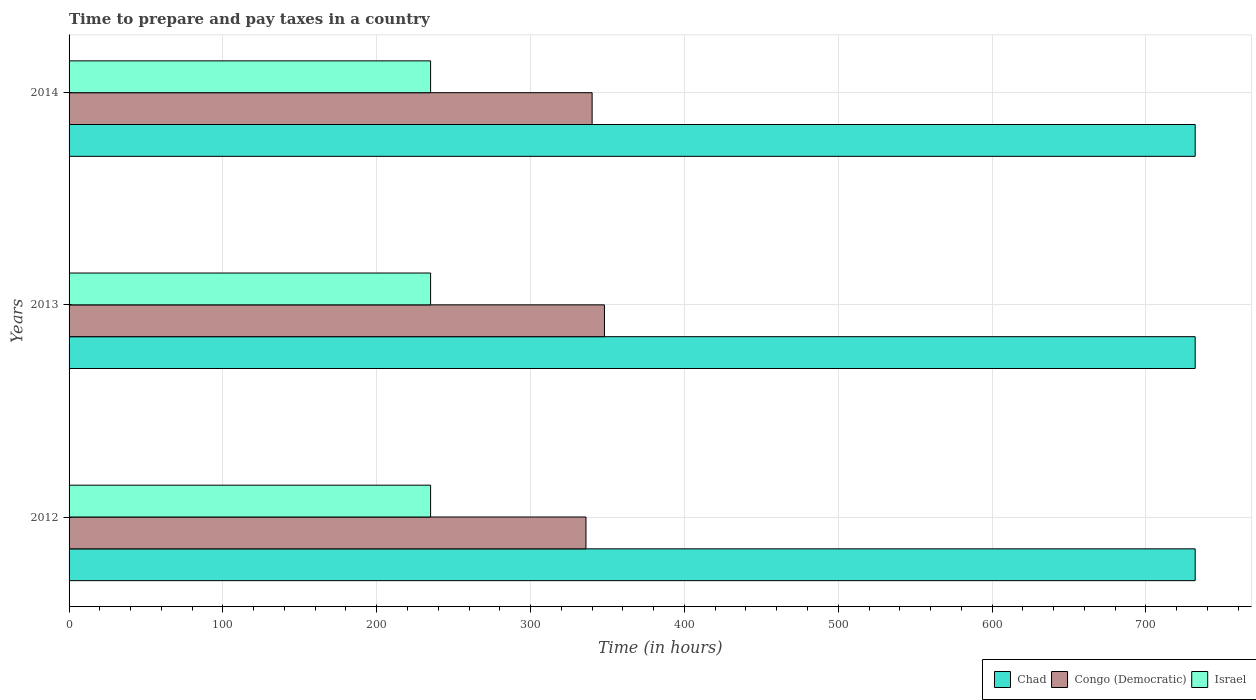How many groups of bars are there?
Your response must be concise. 3. Are the number of bars on each tick of the Y-axis equal?
Your response must be concise. Yes. How many bars are there on the 1st tick from the top?
Ensure brevity in your answer.  3. What is the number of hours required to prepare and pay taxes in Chad in 2012?
Your response must be concise. 732. Across all years, what is the maximum number of hours required to prepare and pay taxes in Israel?
Your answer should be compact. 235. Across all years, what is the minimum number of hours required to prepare and pay taxes in Congo (Democratic)?
Offer a terse response. 336. In which year was the number of hours required to prepare and pay taxes in Israel minimum?
Provide a short and direct response. 2012. What is the total number of hours required to prepare and pay taxes in Chad in the graph?
Provide a short and direct response. 2196. What is the difference between the number of hours required to prepare and pay taxes in Israel in 2014 and the number of hours required to prepare and pay taxes in Congo (Democratic) in 2012?
Ensure brevity in your answer.  -101. What is the average number of hours required to prepare and pay taxes in Congo (Democratic) per year?
Your response must be concise. 341.33. In the year 2014, what is the difference between the number of hours required to prepare and pay taxes in Israel and number of hours required to prepare and pay taxes in Chad?
Ensure brevity in your answer.  -497. In how many years, is the number of hours required to prepare and pay taxes in Israel greater than 200 hours?
Make the answer very short. 3. What is the ratio of the number of hours required to prepare and pay taxes in Chad in 2012 to that in 2014?
Provide a short and direct response. 1. Is the number of hours required to prepare and pay taxes in Congo (Democratic) in 2012 less than that in 2014?
Keep it short and to the point. Yes. What is the difference between the highest and the second highest number of hours required to prepare and pay taxes in Chad?
Your response must be concise. 0. In how many years, is the number of hours required to prepare and pay taxes in Israel greater than the average number of hours required to prepare and pay taxes in Israel taken over all years?
Make the answer very short. 0. What does the 3rd bar from the top in 2012 represents?
Give a very brief answer. Chad. What does the 3rd bar from the bottom in 2013 represents?
Your answer should be compact. Israel. Is it the case that in every year, the sum of the number of hours required to prepare and pay taxes in Congo (Democratic) and number of hours required to prepare and pay taxes in Israel is greater than the number of hours required to prepare and pay taxes in Chad?
Your answer should be very brief. No. Are all the bars in the graph horizontal?
Your response must be concise. Yes. How many years are there in the graph?
Your answer should be compact. 3. What is the difference between two consecutive major ticks on the X-axis?
Give a very brief answer. 100. Are the values on the major ticks of X-axis written in scientific E-notation?
Your response must be concise. No. Does the graph contain any zero values?
Offer a terse response. No. Where does the legend appear in the graph?
Your answer should be very brief. Bottom right. How many legend labels are there?
Your answer should be compact. 3. How are the legend labels stacked?
Give a very brief answer. Horizontal. What is the title of the graph?
Offer a very short reply. Time to prepare and pay taxes in a country. Does "Middle income" appear as one of the legend labels in the graph?
Provide a short and direct response. No. What is the label or title of the X-axis?
Provide a succinct answer. Time (in hours). What is the label or title of the Y-axis?
Provide a succinct answer. Years. What is the Time (in hours) of Chad in 2012?
Your answer should be compact. 732. What is the Time (in hours) of Congo (Democratic) in 2012?
Your response must be concise. 336. What is the Time (in hours) in Israel in 2012?
Make the answer very short. 235. What is the Time (in hours) in Chad in 2013?
Offer a very short reply. 732. What is the Time (in hours) of Congo (Democratic) in 2013?
Offer a terse response. 348. What is the Time (in hours) in Israel in 2013?
Provide a succinct answer. 235. What is the Time (in hours) of Chad in 2014?
Make the answer very short. 732. What is the Time (in hours) in Congo (Democratic) in 2014?
Give a very brief answer. 340. What is the Time (in hours) in Israel in 2014?
Give a very brief answer. 235. Across all years, what is the maximum Time (in hours) in Chad?
Your answer should be compact. 732. Across all years, what is the maximum Time (in hours) in Congo (Democratic)?
Offer a very short reply. 348. Across all years, what is the maximum Time (in hours) of Israel?
Make the answer very short. 235. Across all years, what is the minimum Time (in hours) in Chad?
Provide a succinct answer. 732. Across all years, what is the minimum Time (in hours) in Congo (Democratic)?
Your answer should be compact. 336. Across all years, what is the minimum Time (in hours) of Israel?
Offer a terse response. 235. What is the total Time (in hours) in Chad in the graph?
Keep it short and to the point. 2196. What is the total Time (in hours) of Congo (Democratic) in the graph?
Your response must be concise. 1024. What is the total Time (in hours) in Israel in the graph?
Provide a short and direct response. 705. What is the difference between the Time (in hours) of Chad in 2012 and that in 2013?
Provide a succinct answer. 0. What is the difference between the Time (in hours) in Congo (Democratic) in 2012 and that in 2013?
Your response must be concise. -12. What is the difference between the Time (in hours) in Israel in 2012 and that in 2013?
Your answer should be compact. 0. What is the difference between the Time (in hours) of Chad in 2012 and that in 2014?
Your answer should be very brief. 0. What is the difference between the Time (in hours) of Congo (Democratic) in 2012 and that in 2014?
Your response must be concise. -4. What is the difference between the Time (in hours) in Chad in 2013 and that in 2014?
Offer a terse response. 0. What is the difference between the Time (in hours) of Chad in 2012 and the Time (in hours) of Congo (Democratic) in 2013?
Offer a very short reply. 384. What is the difference between the Time (in hours) of Chad in 2012 and the Time (in hours) of Israel in 2013?
Make the answer very short. 497. What is the difference between the Time (in hours) of Congo (Democratic) in 2012 and the Time (in hours) of Israel in 2013?
Provide a succinct answer. 101. What is the difference between the Time (in hours) of Chad in 2012 and the Time (in hours) of Congo (Democratic) in 2014?
Provide a succinct answer. 392. What is the difference between the Time (in hours) of Chad in 2012 and the Time (in hours) of Israel in 2014?
Give a very brief answer. 497. What is the difference between the Time (in hours) of Congo (Democratic) in 2012 and the Time (in hours) of Israel in 2014?
Provide a short and direct response. 101. What is the difference between the Time (in hours) of Chad in 2013 and the Time (in hours) of Congo (Democratic) in 2014?
Offer a terse response. 392. What is the difference between the Time (in hours) of Chad in 2013 and the Time (in hours) of Israel in 2014?
Provide a succinct answer. 497. What is the difference between the Time (in hours) of Congo (Democratic) in 2013 and the Time (in hours) of Israel in 2014?
Keep it short and to the point. 113. What is the average Time (in hours) of Chad per year?
Your answer should be compact. 732. What is the average Time (in hours) in Congo (Democratic) per year?
Give a very brief answer. 341.33. What is the average Time (in hours) in Israel per year?
Provide a succinct answer. 235. In the year 2012, what is the difference between the Time (in hours) in Chad and Time (in hours) in Congo (Democratic)?
Ensure brevity in your answer.  396. In the year 2012, what is the difference between the Time (in hours) of Chad and Time (in hours) of Israel?
Your answer should be very brief. 497. In the year 2012, what is the difference between the Time (in hours) of Congo (Democratic) and Time (in hours) of Israel?
Offer a very short reply. 101. In the year 2013, what is the difference between the Time (in hours) of Chad and Time (in hours) of Congo (Democratic)?
Provide a succinct answer. 384. In the year 2013, what is the difference between the Time (in hours) in Chad and Time (in hours) in Israel?
Provide a succinct answer. 497. In the year 2013, what is the difference between the Time (in hours) of Congo (Democratic) and Time (in hours) of Israel?
Provide a succinct answer. 113. In the year 2014, what is the difference between the Time (in hours) in Chad and Time (in hours) in Congo (Democratic)?
Make the answer very short. 392. In the year 2014, what is the difference between the Time (in hours) of Chad and Time (in hours) of Israel?
Provide a succinct answer. 497. In the year 2014, what is the difference between the Time (in hours) of Congo (Democratic) and Time (in hours) of Israel?
Offer a very short reply. 105. What is the ratio of the Time (in hours) in Chad in 2012 to that in 2013?
Your response must be concise. 1. What is the ratio of the Time (in hours) of Congo (Democratic) in 2012 to that in 2013?
Provide a succinct answer. 0.97. What is the ratio of the Time (in hours) in Chad in 2012 to that in 2014?
Offer a terse response. 1. What is the ratio of the Time (in hours) in Israel in 2012 to that in 2014?
Offer a terse response. 1. What is the ratio of the Time (in hours) of Congo (Democratic) in 2013 to that in 2014?
Your answer should be very brief. 1.02. What is the ratio of the Time (in hours) in Israel in 2013 to that in 2014?
Make the answer very short. 1. What is the difference between the highest and the second highest Time (in hours) in Congo (Democratic)?
Make the answer very short. 8. What is the difference between the highest and the second highest Time (in hours) in Israel?
Your answer should be very brief. 0. What is the difference between the highest and the lowest Time (in hours) in Chad?
Make the answer very short. 0. What is the difference between the highest and the lowest Time (in hours) in Israel?
Your answer should be very brief. 0. 